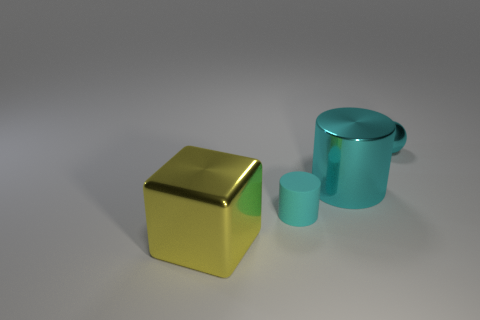Add 3 big cyan metallic objects. How many objects exist? 7 Subtract all balls. How many objects are left? 3 Subtract all big green metallic cylinders. Subtract all small metal balls. How many objects are left? 3 Add 3 tiny metallic things. How many tiny metallic things are left? 4 Add 2 big brown metal cubes. How many big brown metal cubes exist? 2 Subtract 0 blue blocks. How many objects are left? 4 